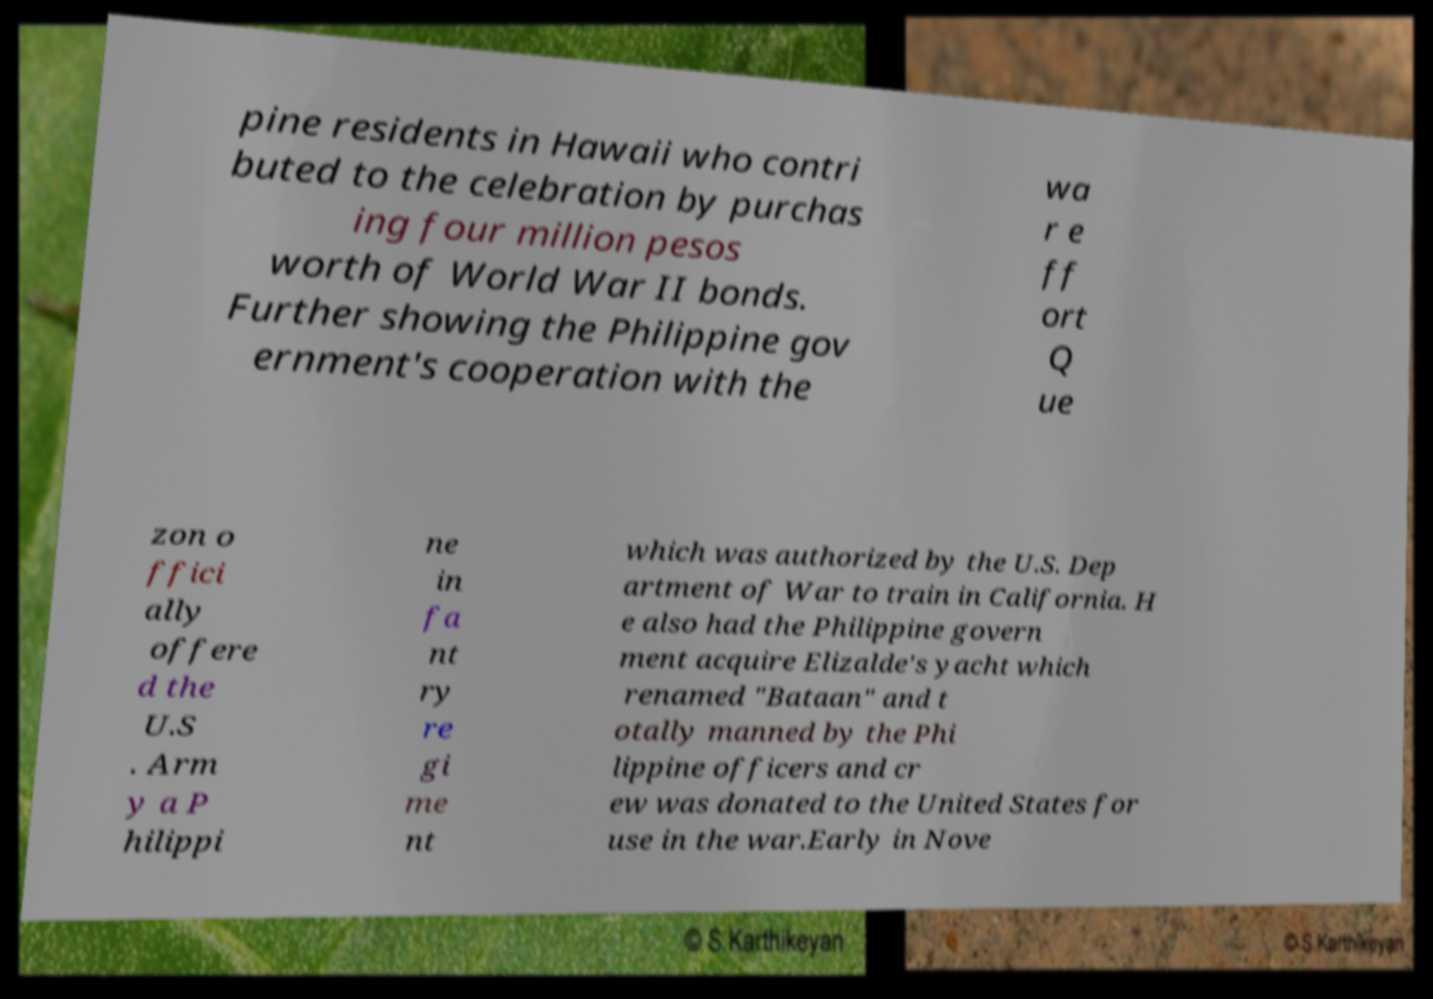Can you accurately transcribe the text from the provided image for me? pine residents in Hawaii who contri buted to the celebration by purchas ing four million pesos worth of World War II bonds. Further showing the Philippine gov ernment's cooperation with the wa r e ff ort Q ue zon o ffici ally offere d the U.S . Arm y a P hilippi ne in fa nt ry re gi me nt which was authorized by the U.S. Dep artment of War to train in California. H e also had the Philippine govern ment acquire Elizalde's yacht which renamed "Bataan" and t otally manned by the Phi lippine officers and cr ew was donated to the United States for use in the war.Early in Nove 